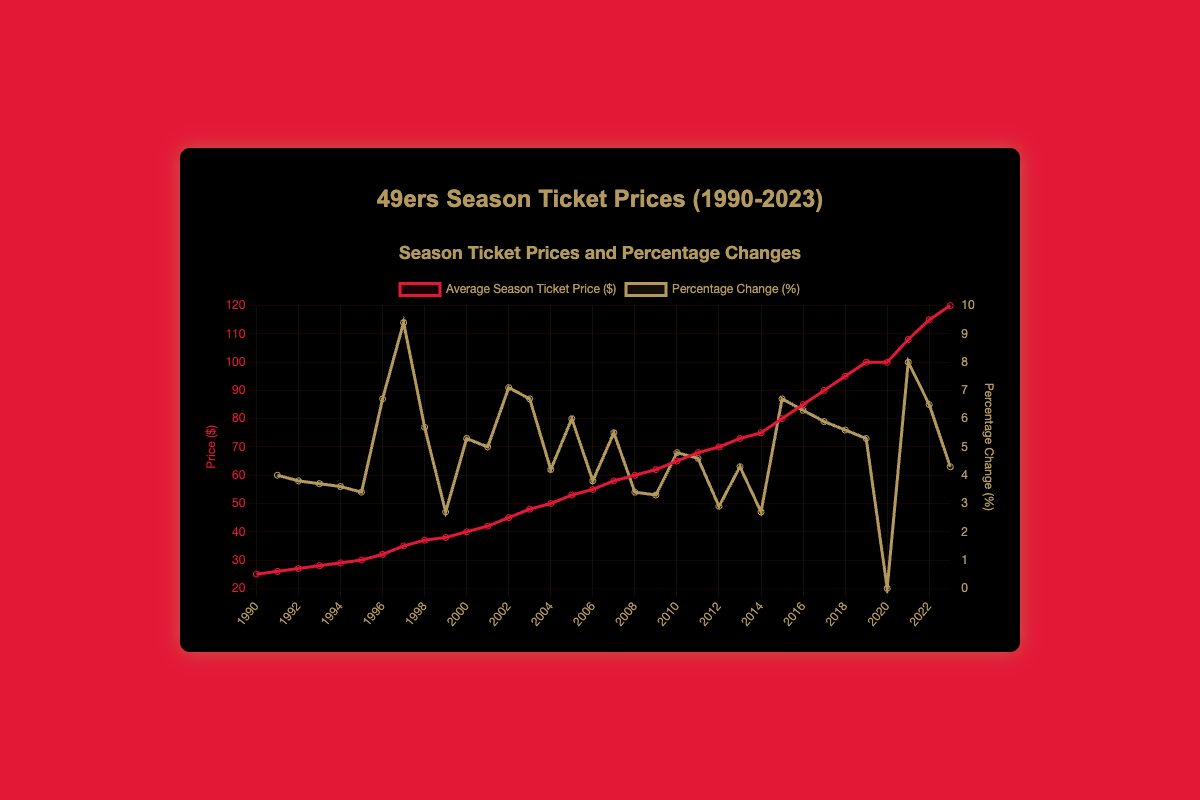What's the average season ticket price from 1990 to 2000? To find the average, we sum the prices from 1990 to 2000: 25 + 26 + 27 + 28 + 29 + 30 + 32 + 35 + 37 + 38 + 40 = 347. Then, divide by the number of years (11): 347 / 11 = 31.55
Answer: 31.55 Which year had the highest percentage change in ticket prices? By examining the percentage change data, the year with the highest percentage change is 1997 with a 9.4% increase.
Answer: 1997 Between which years did the ticket price remain the same? By looking at the price trends, the ticket price remained the same between the years 2019 and 2020 at $100.
Answer: 2019 to 2020 In which year was the average season ticket price $75? The data indicates that the average season ticket price was $75 in the year 2014.
Answer: 2014 How much did the ticket price increase from 1990 to 2023? The ticket prices in 1990 and 2023 are $25 and $120, respectively. The increase is calculated by subtracting the price in 1990 from the price in 2023: 120 - 25 = 95
Answer: 95 What was the percentage change in ticket prices in 2015 compared to the previous year? The percentage change in 2015 is 6.7%. This is already provided in the data.
Answer: 6.7% Compare the percentage changes in 2003 and 2004. Which year had a higher percentage change? In 2003, the percentage change was 6.7%, and in 2004 it was 4.2%. Therefore, 2003 had a higher percentage change.
Answer: 2003 What is the color used to represent the average season ticket prices on the chart? The average season ticket prices are represented by the color red on the chart.
Answer: Red Calculate the total percentage change from 2020 to 2023. The percentage changes from 2020 to 2023 are 0%, 8%, 6.5%, and 4.3% respectively. Adding these up: 0 + 8 + 6.5 + 4.3 = 18.8
Answer: 18.8 Which year had the least percentage change in ticket prices? According to the data, the year 2020 had the least percentage change in ticket prices, which was 0%.
Answer: 2020 